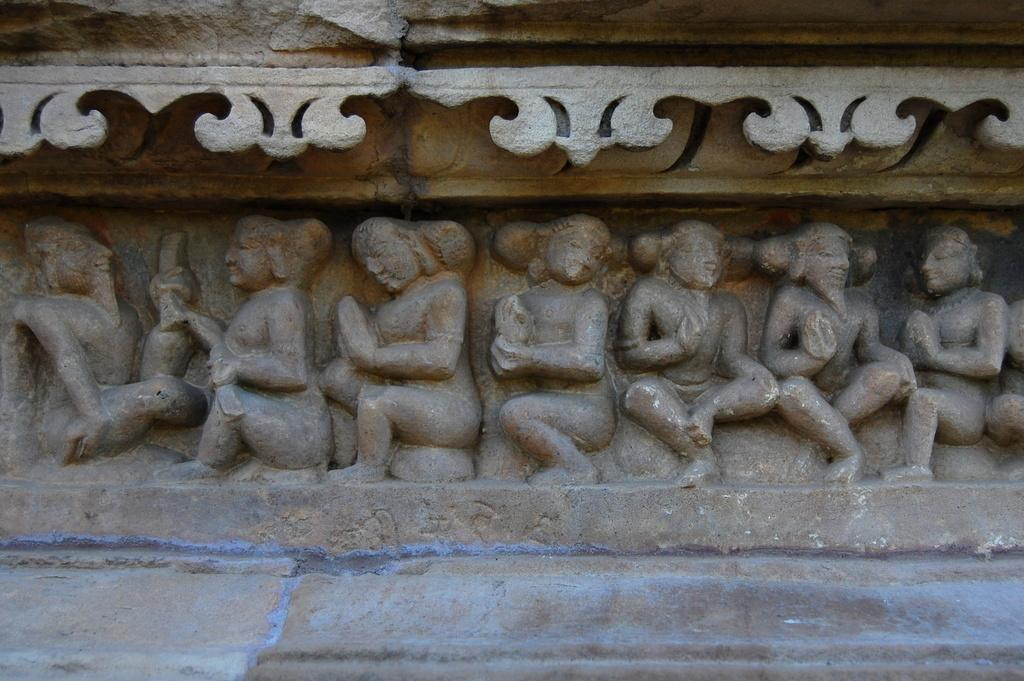What is the main subject in the center of the image? There are sculptures in the center of the image. What can be seen in the background of the image? There is a wall visible in the background of the image. How many pages does the bird have in the image? There is no bird present in the image, so the number of pages cannot be determined. 